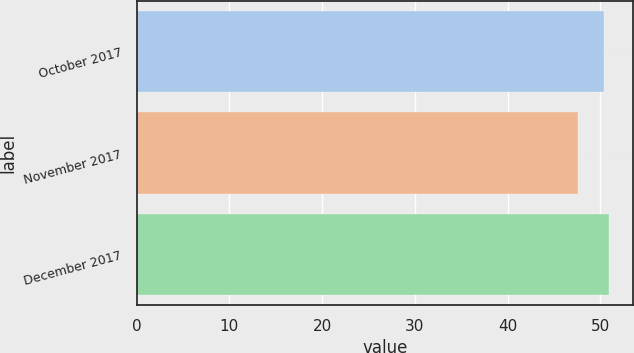<chart> <loc_0><loc_0><loc_500><loc_500><bar_chart><fcel>October 2017<fcel>November 2017<fcel>December 2017<nl><fcel>50.37<fcel>47.59<fcel>50.96<nl></chart> 